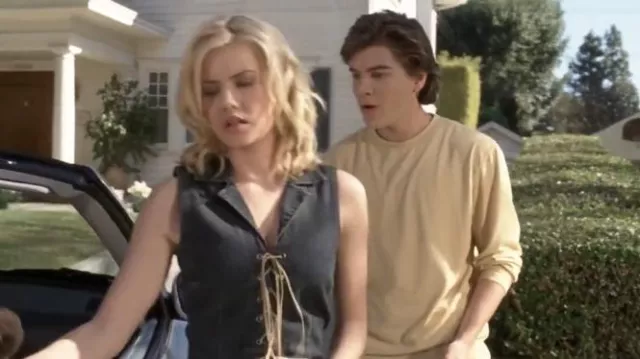Can you tell me more about the context of this scene? This scene seems to encapsulate a moment of emotional conflict between the two characters. The setting appears to be a suburban neighborhood, which adds an element of normalcy and contrast to their apparent disagreement. The presence of the car indicates that they might be in the midst of a journey, perhaps hinting at a story of departure or a pivotal decision-making moment. The body language and expressions suggest a deeper narrative of tension and unresolved issues. What might be some potential backstories for these characters? There are many intriguing possibilities for the backstories of these characters. One scenario could be that they're a couple facing a significant relationship challenge. Perhaps they've just had an argument about their future together, and the woman feels the need to walk away to gather her thoughts. The young man's concern might suggest he wants to resolve the conflict but is unsure how to approach it. Alternatively, they could be siblings dealing with a family crisis, the tension arising from differing opinions on how to handle the situation. The car might symbolize a journey they are on together, making the scene a metaphor for their relationship's journey. 